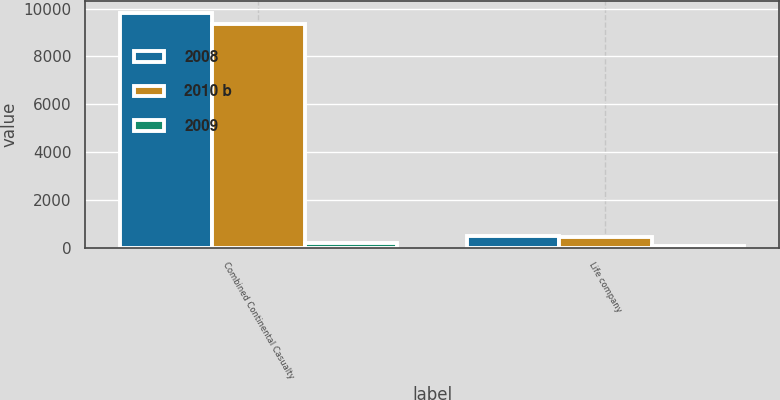Convert chart. <chart><loc_0><loc_0><loc_500><loc_500><stacked_bar_chart><ecel><fcel>Combined Continental Casualty<fcel>Life company<nl><fcel>2008<fcel>9821<fcel>498<nl><fcel>2010 b<fcel>9338<fcel>448<nl><fcel>2009<fcel>172<fcel>51<nl></chart> 